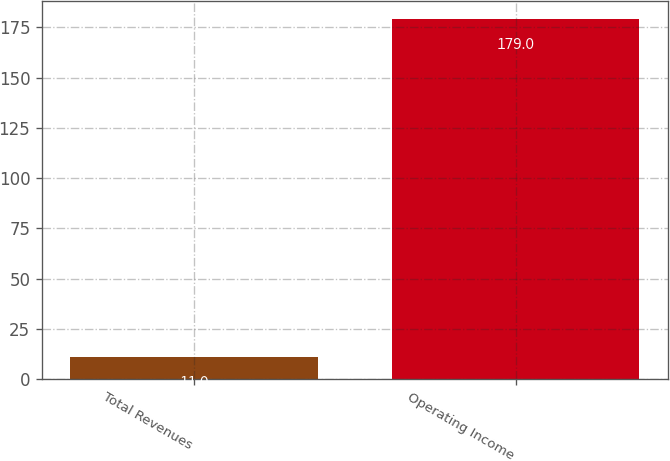<chart> <loc_0><loc_0><loc_500><loc_500><bar_chart><fcel>Total Revenues<fcel>Operating Income<nl><fcel>11<fcel>179<nl></chart> 